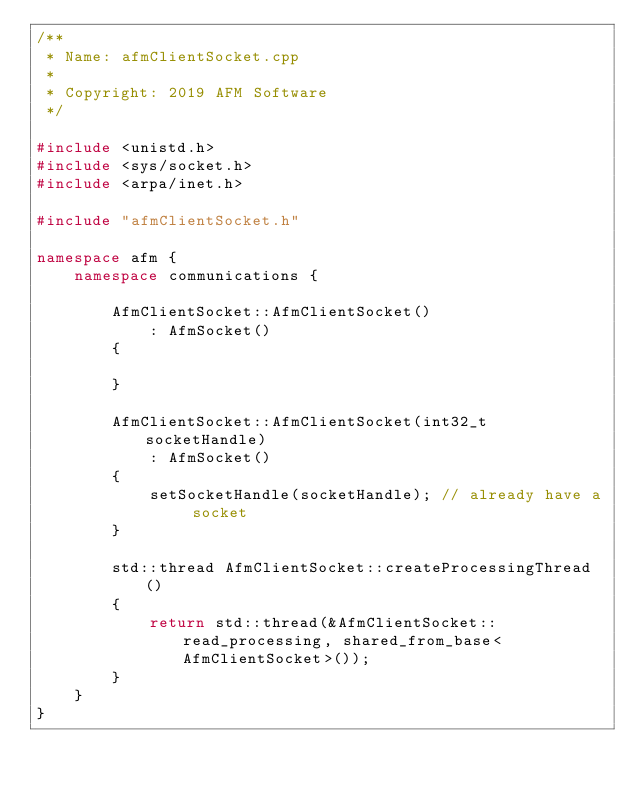<code> <loc_0><loc_0><loc_500><loc_500><_C++_>/**
 * Name: afmClientSocket.cpp
 * 
 * Copyright: 2019 AFM Software
 */

#include <unistd.h>
#include <sys/socket.h>
#include <arpa/inet.h>

#include "afmClientSocket.h"

namespace afm {
    namespace communications {

        AfmClientSocket::AfmClientSocket()
            : AfmSocket()
        {

        }

        AfmClientSocket::AfmClientSocket(int32_t socketHandle)
            : AfmSocket()
        {
            setSocketHandle(socketHandle); // already have a socket
        }

        std::thread AfmClientSocket::createProcessingThread()
        {
            return std::thread(&AfmClientSocket::read_processing, shared_from_base<AfmClientSocket>());
        }
    }
}
</code> 